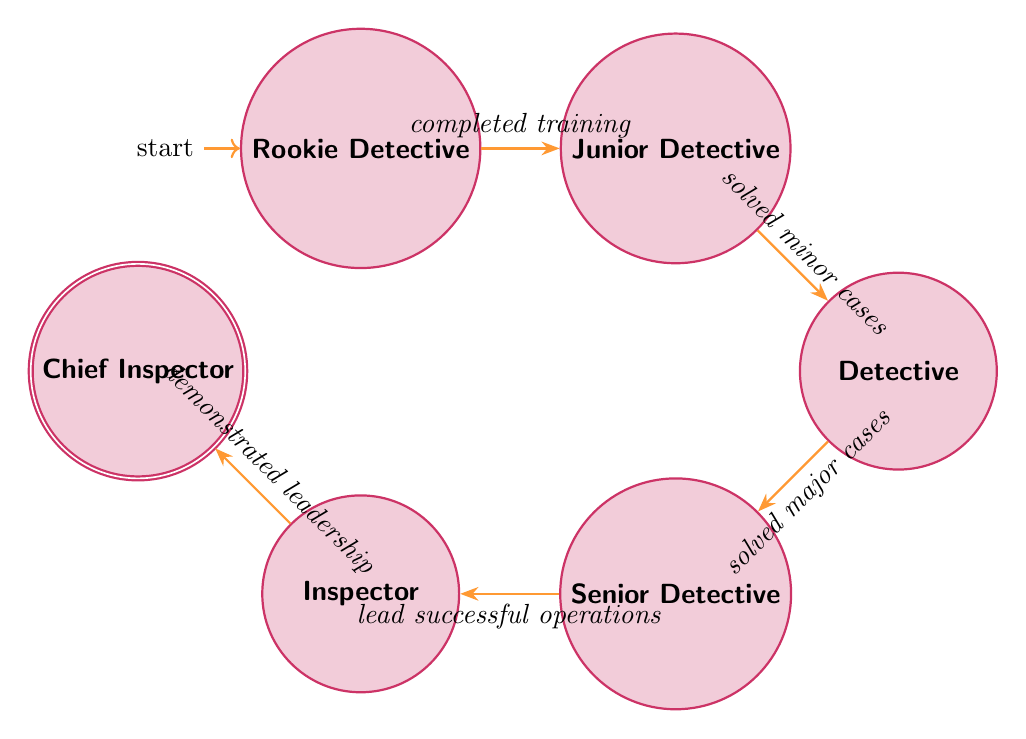What is the initial state in the diagram? The initial state is indicated with an 'initial' label, which is the first state before any transitions have occurred. In this case, it is labeled as "Rookie Detective."
Answer: Rookie Detective How many states are represented in the diagram? The total number of states is counted by looking at each named state present in the diagram. There are six distinct states: Rookie Detective, Junior Detective, Detective, Senior Detective, Inspector, and Chief Inspector.
Answer: 6 What event leads from Junior Detective to Detective? The event that facilitates the transition from the state of Junior Detective to Detective is indicated in the diagram as "solved minor cases." This event is necessary to move forward in the career path.
Answer: solved minor cases Which state involves leading a team? The state that is responsible for leading a team is identified as "Senior Detective." The description of this state confirms that the individual in this role often leads team investigations.
Answer: Senior Detective What is the final state in the career path? The final state is shown as the end of the transition chain in the diagram, which is "Chief Inspector." This indicates the ultimate position achieved within the career path of a detective.
Answer: Chief Inspector What event transitions the state from Inspector to Chief Inspector? The transition from Inspector to Chief Inspector is achieved through the event labeled "demonstrated leadership," indicating a necessary accomplishment for advancement to the highest position shown.
Answer: demonstrated leadership How many transitions are shown from the Detective state? The number of transitions from the Detective state is determined by examining the outgoing edges from this state. There is one transition leading to Senior Detective, indicating the next step in the career path.
Answer: 1 Which state indicates the start of a detective's training? The state that signifies the beginning of a detective's training is "Rookie Detective," where the individual is newly graduated and learning the basics of detective work.
Answer: Rookie Detective What role comes after the Senior Detective state? The role that follows after progressing from the Senior Detective state is "Inspector," as indicated by the transition labeled "lead successful operations."
Answer: Inspector 